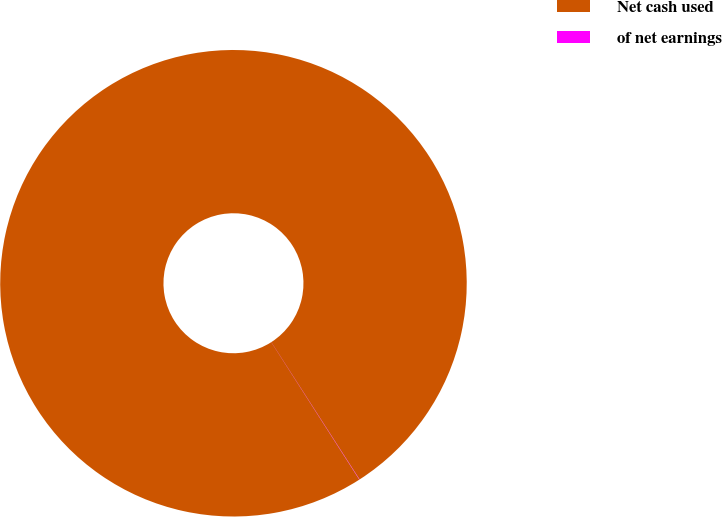Convert chart. <chart><loc_0><loc_0><loc_500><loc_500><pie_chart><fcel>Net cash used<fcel>of net earnings<nl><fcel>99.98%<fcel>0.02%<nl></chart> 